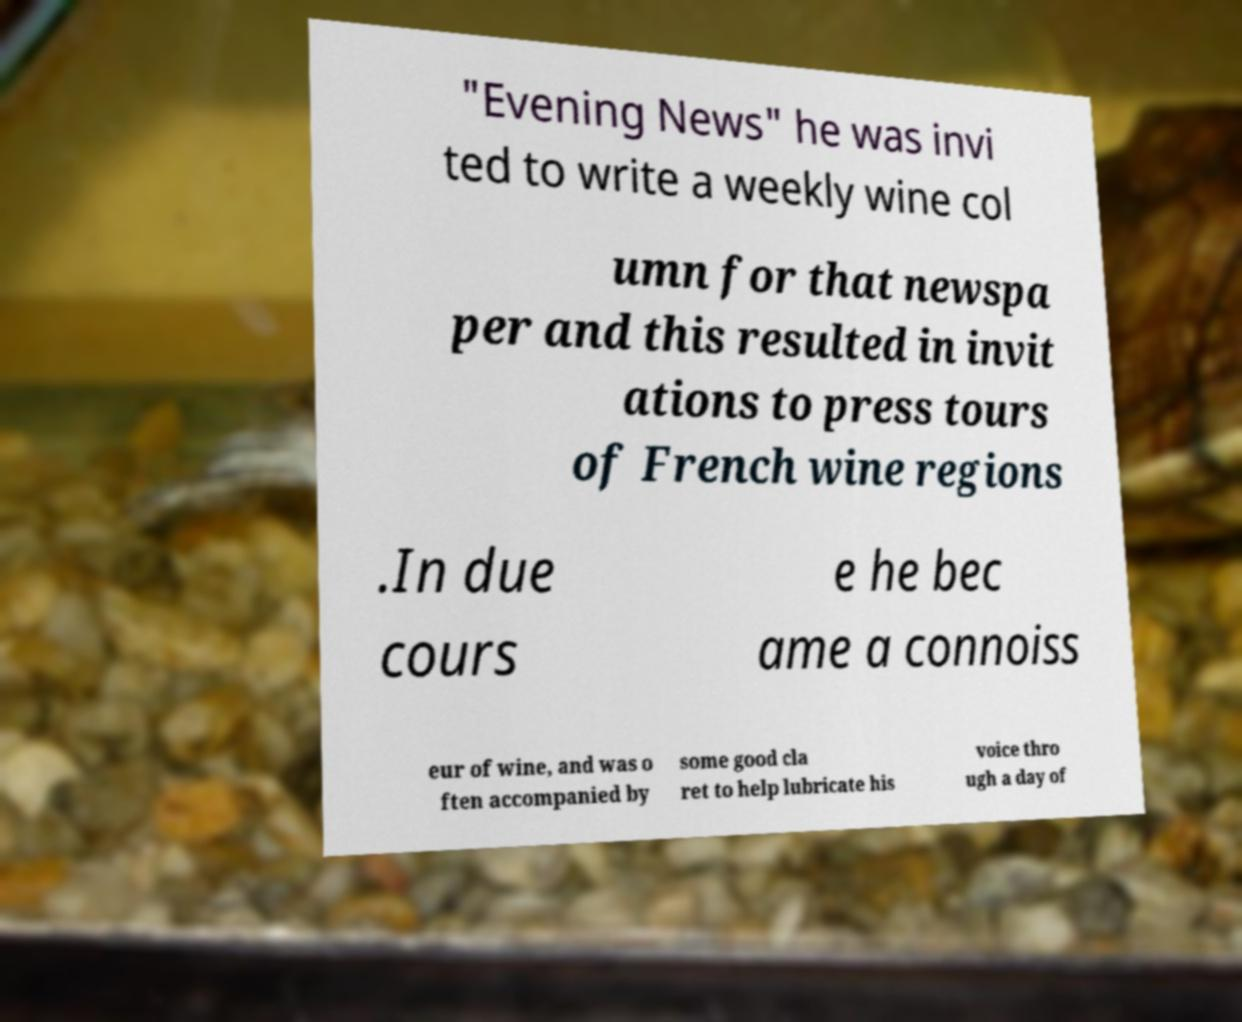There's text embedded in this image that I need extracted. Can you transcribe it verbatim? "Evening News" he was invi ted to write a weekly wine col umn for that newspa per and this resulted in invit ations to press tours of French wine regions .In due cours e he bec ame a connoiss eur of wine, and was o ften accompanied by some good cla ret to help lubricate his voice thro ugh a day of 